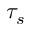<formula> <loc_0><loc_0><loc_500><loc_500>\tau _ { s }</formula> 